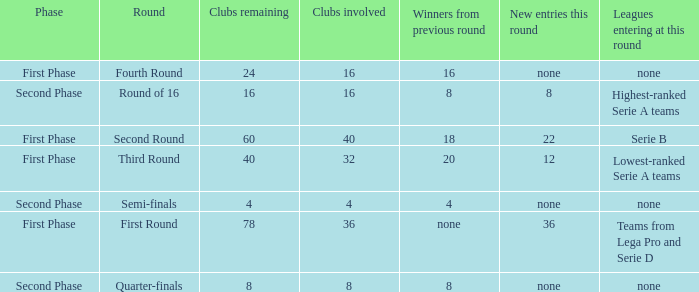The new entries this round was shown to be 12, in which phase would you find this? First Phase. 